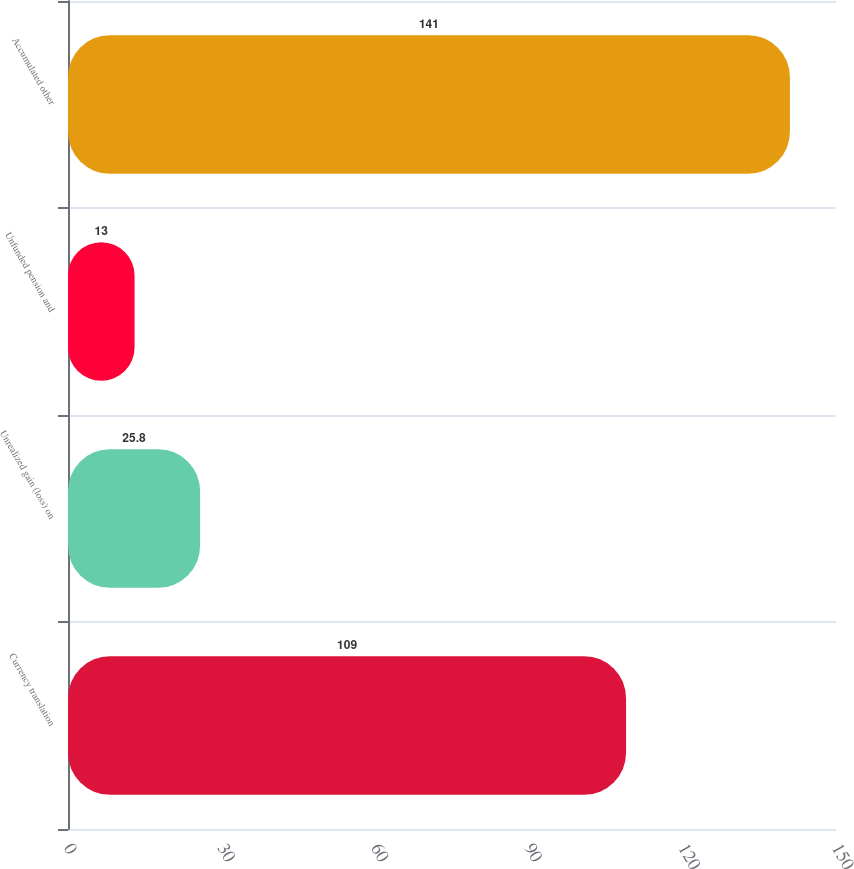<chart> <loc_0><loc_0><loc_500><loc_500><bar_chart><fcel>Currency translation<fcel>Unrealized gain (loss) on<fcel>Unfunded pension and<fcel>Accumulated other<nl><fcel>109<fcel>25.8<fcel>13<fcel>141<nl></chart> 